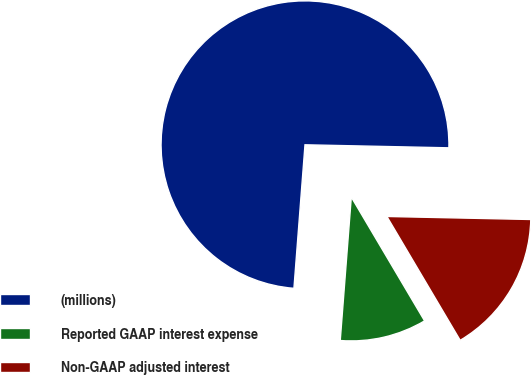Convert chart to OTSL. <chart><loc_0><loc_0><loc_500><loc_500><pie_chart><fcel>(millions)<fcel>Reported GAAP interest expense<fcel>Non-GAAP adjusted interest<nl><fcel>74.11%<fcel>9.73%<fcel>16.16%<nl></chart> 